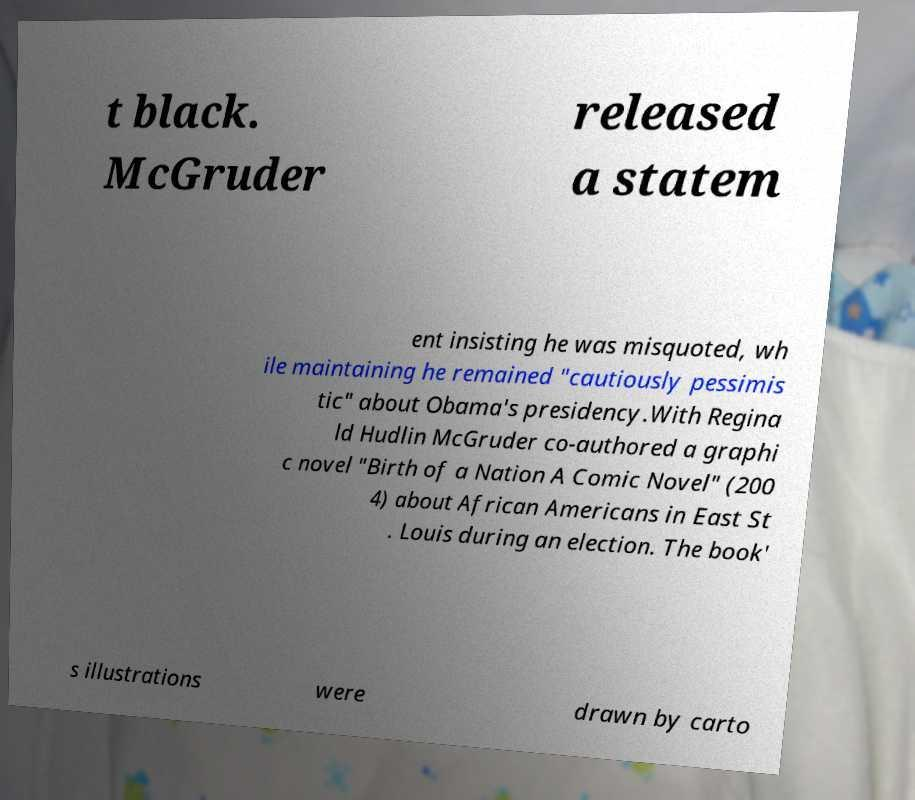Could you assist in decoding the text presented in this image and type it out clearly? t black. McGruder released a statem ent insisting he was misquoted, wh ile maintaining he remained "cautiously pessimis tic" about Obama's presidency.With Regina ld Hudlin McGruder co-authored a graphi c novel "Birth of a Nation A Comic Novel" (200 4) about African Americans in East St . Louis during an election. The book' s illustrations were drawn by carto 